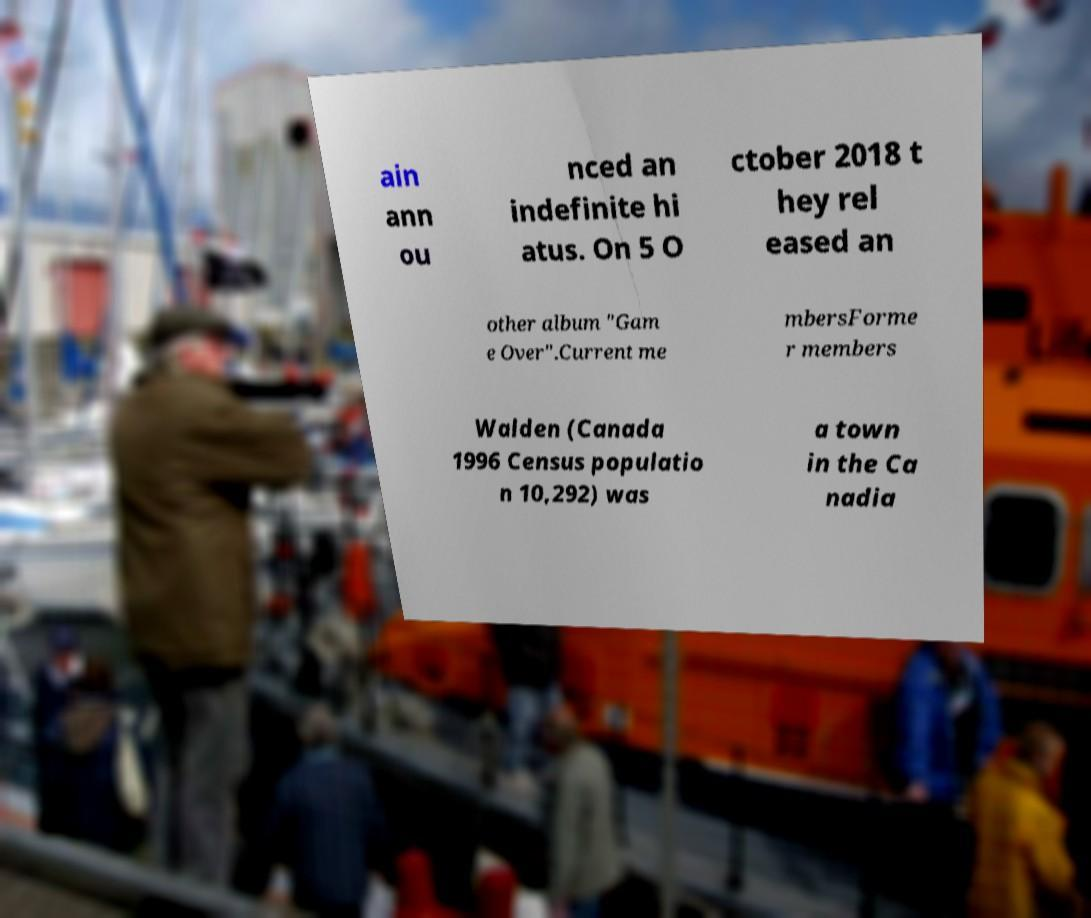What messages or text are displayed in this image? I need them in a readable, typed format. ain ann ou nced an indefinite hi atus. On 5 O ctober 2018 t hey rel eased an other album "Gam e Over".Current me mbersForme r members Walden (Canada 1996 Census populatio n 10,292) was a town in the Ca nadia 